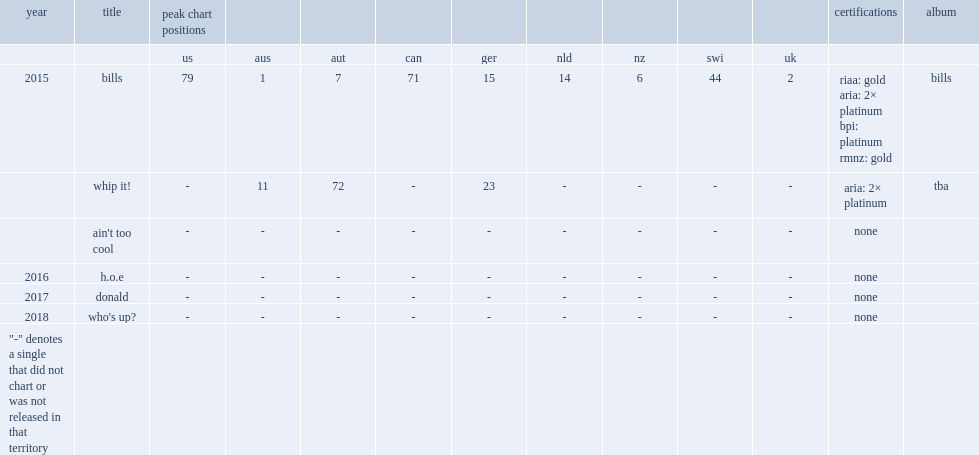In 2015, what is the peak chart position for lunchmoney lewis released debut single "bills" on the aria charts? 1.0. 